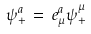Convert formula to latex. <formula><loc_0><loc_0><loc_500><loc_500>\psi _ { + } ^ { a } \, = \, e ^ { a } _ { \mu } \psi _ { + } ^ { \mu }</formula> 